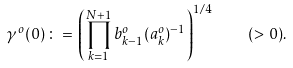Convert formula to latex. <formula><loc_0><loc_0><loc_500><loc_500>\gamma ^ { o } ( 0 ) \, \colon = \, \left ( \prod _ { k = 1 } ^ { N + 1 } b _ { k - 1 } ^ { o } ( a _ { k } ^ { o } ) ^ { - 1 } \right ) ^ { 1 / 4 } \quad ( > \, 0 ) .</formula> 